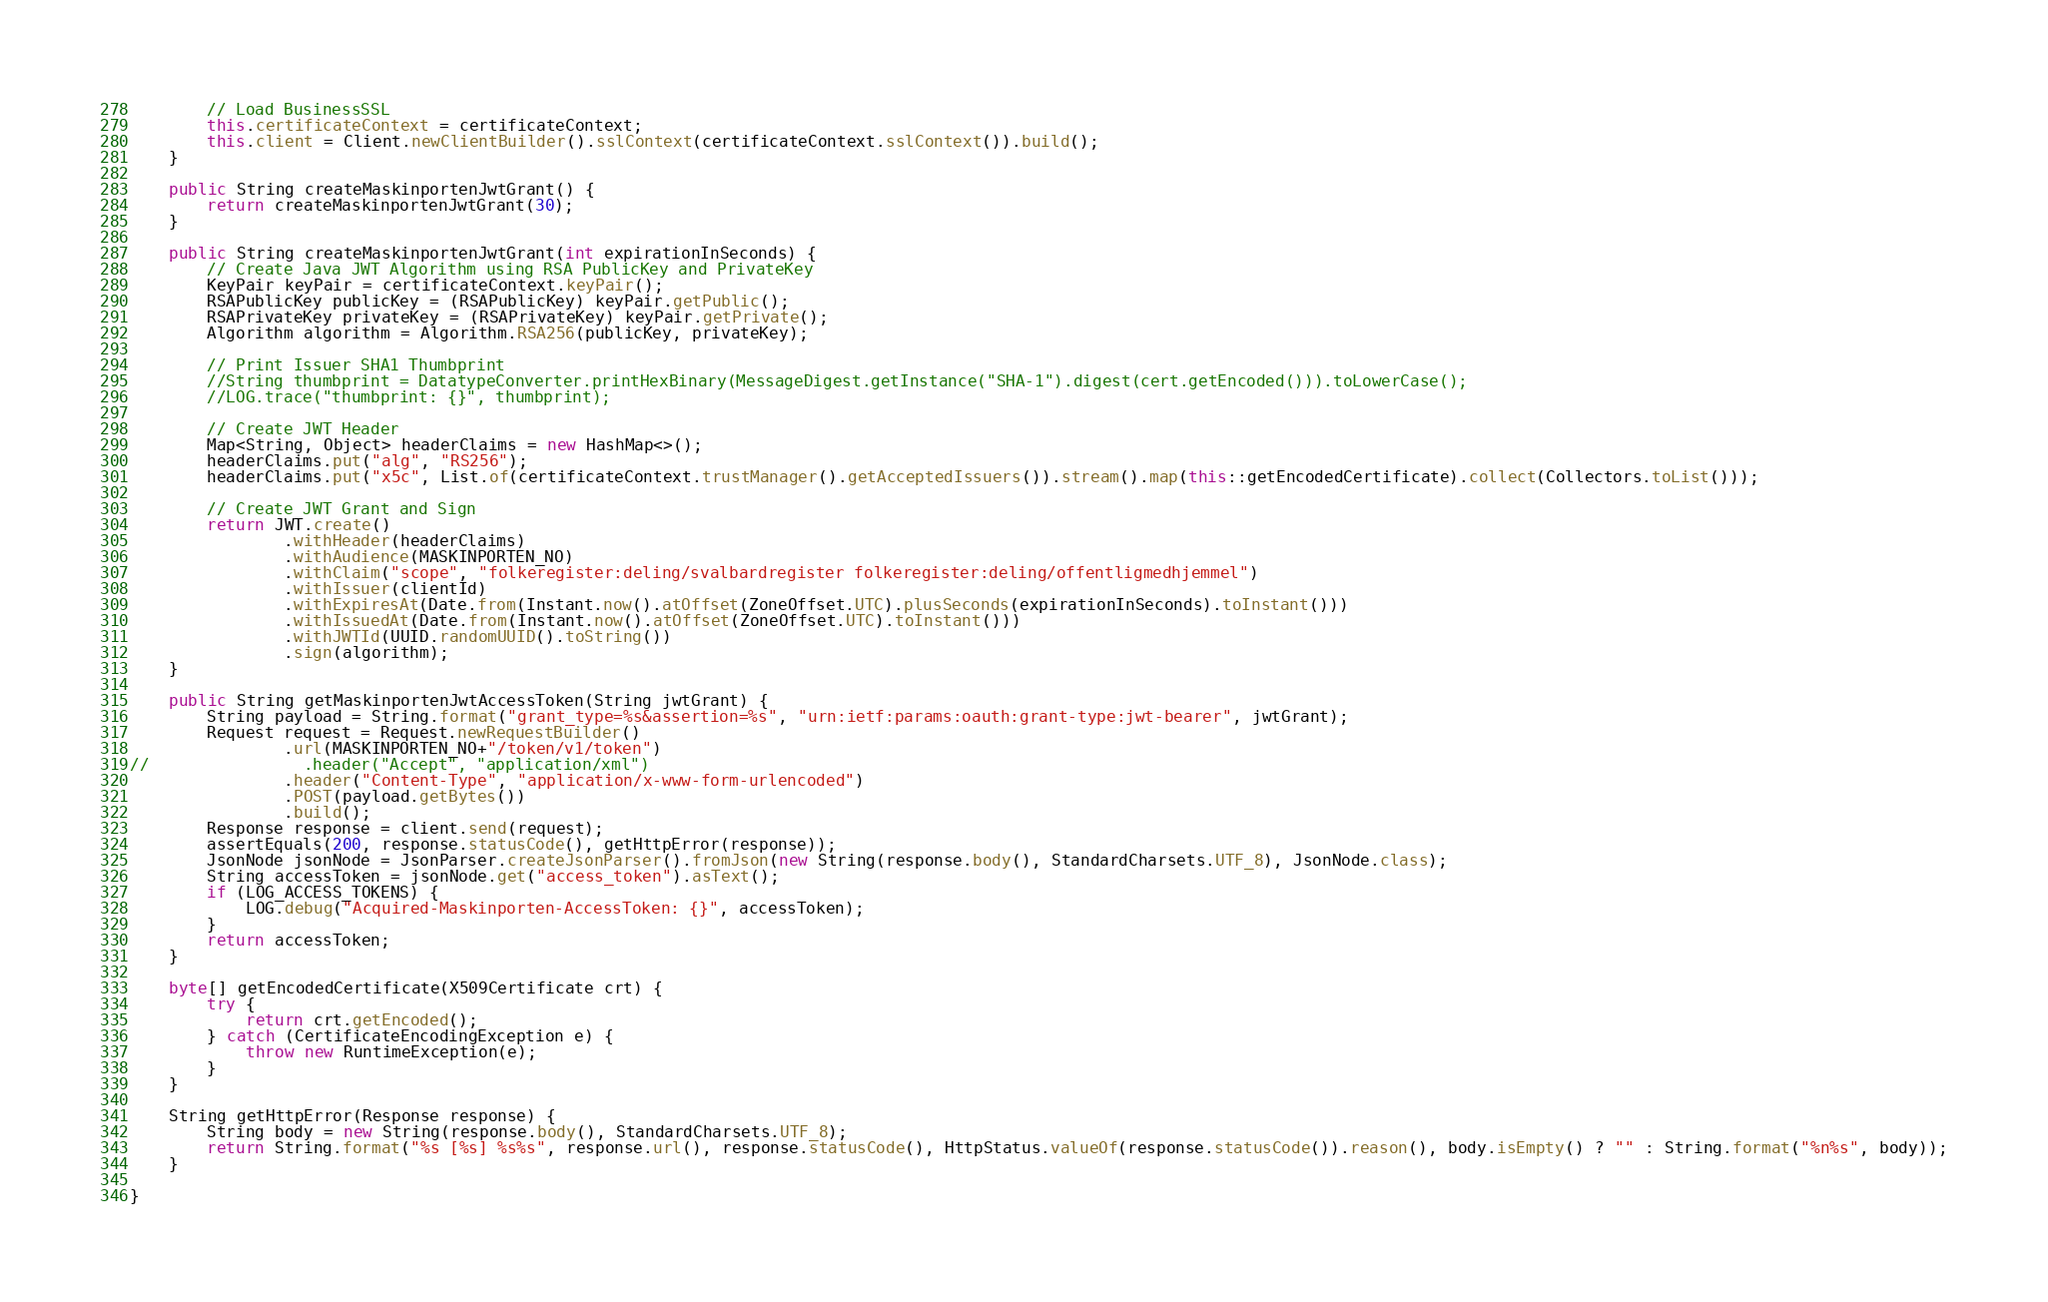<code> <loc_0><loc_0><loc_500><loc_500><_Java_>        // Load BusinessSSL
        this.certificateContext = certificateContext;
        this.client = Client.newClientBuilder().sslContext(certificateContext.sslContext()).build();
    }

    public String createMaskinportenJwtGrant() {
        return createMaskinportenJwtGrant(30);
    }

    public String createMaskinportenJwtGrant(int expirationInSeconds) {
        // Create Java JWT Algorithm using RSA PublicKey and PrivateKey
        KeyPair keyPair = certificateContext.keyPair();
        RSAPublicKey publicKey = (RSAPublicKey) keyPair.getPublic();
        RSAPrivateKey privateKey = (RSAPrivateKey) keyPair.getPrivate();
        Algorithm algorithm = Algorithm.RSA256(publicKey, privateKey);

        // Print Issuer SHA1 Thumbprint
        //String thumbprint = DatatypeConverter.printHexBinary(MessageDigest.getInstance("SHA-1").digest(cert.getEncoded())).toLowerCase();
        //LOG.trace("thumbprint: {}", thumbprint);

        // Create JWT Header
        Map<String, Object> headerClaims = new HashMap<>();
        headerClaims.put("alg", "RS256");
        headerClaims.put("x5c", List.of(certificateContext.trustManager().getAcceptedIssuers()).stream().map(this::getEncodedCertificate).collect(Collectors.toList()));

        // Create JWT Grant and Sign
        return JWT.create()
                .withHeader(headerClaims)
                .withAudience(MASKINPORTEN_NO)
                .withClaim("scope", "folkeregister:deling/svalbardregister folkeregister:deling/offentligmedhjemmel")
                .withIssuer(clientId)
                .withExpiresAt(Date.from(Instant.now().atOffset(ZoneOffset.UTC).plusSeconds(expirationInSeconds).toInstant()))
                .withIssuedAt(Date.from(Instant.now().atOffset(ZoneOffset.UTC).toInstant()))
                .withJWTId(UUID.randomUUID().toString())
                .sign(algorithm);
    }

    public String getMaskinportenJwtAccessToken(String jwtGrant) {
        String payload = String.format("grant_type=%s&assertion=%s", "urn:ietf:params:oauth:grant-type:jwt-bearer", jwtGrant);
        Request request = Request.newRequestBuilder()
                .url(MASKINPORTEN_NO+"/token/v1/token")
//                .header("Accept", "application/xml")
                .header("Content-Type", "application/x-www-form-urlencoded")
                .POST(payload.getBytes())
                .build();
        Response response = client.send(request);
        assertEquals(200, response.statusCode(), getHttpError(response));
        JsonNode jsonNode = JsonParser.createJsonParser().fromJson(new String(response.body(), StandardCharsets.UTF_8), JsonNode.class);
        String accessToken = jsonNode.get("access_token").asText();
        if (LOG_ACCESS_TOKENS) {
            LOG.debug("Acquired-Maskinporten-AccessToken: {}", accessToken);
        }
        return accessToken;
    }

    byte[] getEncodedCertificate(X509Certificate crt) {
        try {
            return crt.getEncoded();
        } catch (CertificateEncodingException e) {
            throw new RuntimeException(e);
        }
    }

    String getHttpError(Response response) {
        String body = new String(response.body(), StandardCharsets.UTF_8);
        return String.format("%s [%s] %s%s", response.url(), response.statusCode(), HttpStatus.valueOf(response.statusCode()).reason(), body.isEmpty() ? "" : String.format("%n%s", body));
    }

}
</code> 